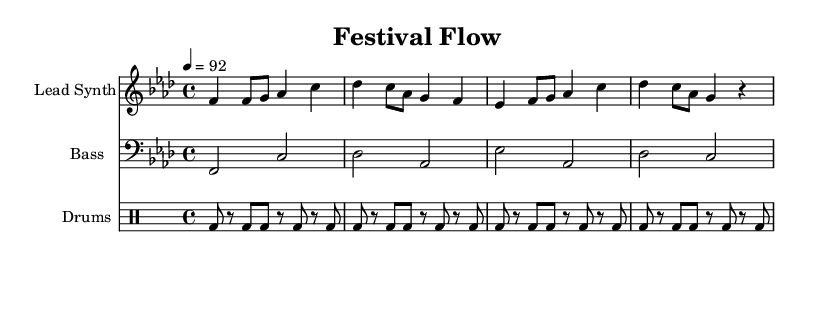What is the key signature of this music? The key signature shown is F minor, as indicated by the presence of four flats (B♭, E♭, A♭, D♭) in the key signature area at the beginning of the staff.
Answer: F minor What is the time signature of this music? The time signature displayed is 4/4, as shown in the section near the beginning of the staff, indicating four beats per measure and a quarter note receives one beat.
Answer: 4/4 What is the tempo marking of this music? The tempo is marked as 4 equals 92, which indicates that the quarter note gets 92 beats per minute. This information is found in the tempo marking section at the start of the score.
Answer: 92 How many measures are in the Lead Synth part? The Lead Synth part has a total of four measures, which can be counted by identifying the vertical bar lines separating each measure within the staff.
Answer: 4 What instrument is specified as "Bass"? The instrument named "Bass" is indicated in the second staff, identifying its role and instrument designation.
Answer: Bass What are the lyrics associated with the Lead Synth part? The lyrics are clearly matched to the Lead Synth melody and include the phrases discussing change and adaptation in the context of seasonal trends, which are visible beneath the Lead Synth staff.
Answer: Seasons change, gotta rearrange What is the primary theme of the lyrics in this piece? The primary theme centers around adapting to seasonal changes and thriving in the environment of music festivals, reflecting the entrepreneurial spirit of flexibility in business strategy as expressed in the lyrics.
Answer: Adaptation 